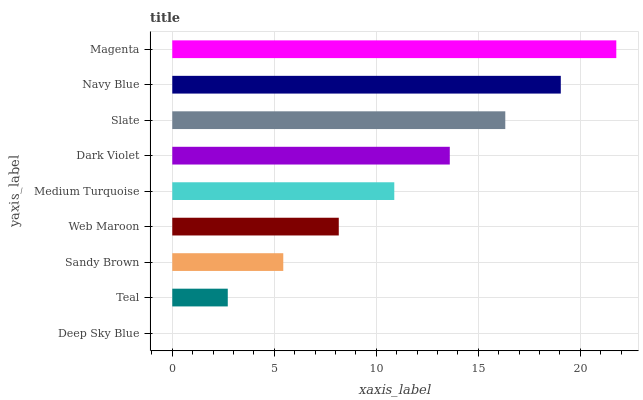Is Deep Sky Blue the minimum?
Answer yes or no. Yes. Is Magenta the maximum?
Answer yes or no. Yes. Is Teal the minimum?
Answer yes or no. No. Is Teal the maximum?
Answer yes or no. No. Is Teal greater than Deep Sky Blue?
Answer yes or no. Yes. Is Deep Sky Blue less than Teal?
Answer yes or no. Yes. Is Deep Sky Blue greater than Teal?
Answer yes or no. No. Is Teal less than Deep Sky Blue?
Answer yes or no. No. Is Medium Turquoise the high median?
Answer yes or no. Yes. Is Medium Turquoise the low median?
Answer yes or no. Yes. Is Sandy Brown the high median?
Answer yes or no. No. Is Navy Blue the low median?
Answer yes or no. No. 